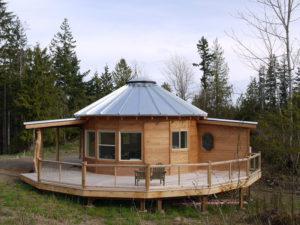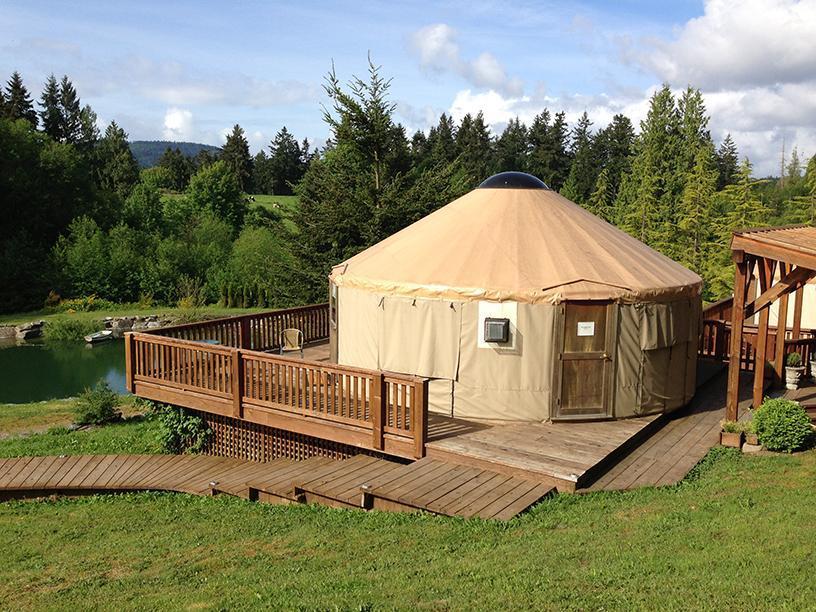The first image is the image on the left, the second image is the image on the right. Given the left and right images, does the statement "A round house in one image has a metal roof with fan-shaped segments." hold true? Answer yes or no. Yes. 